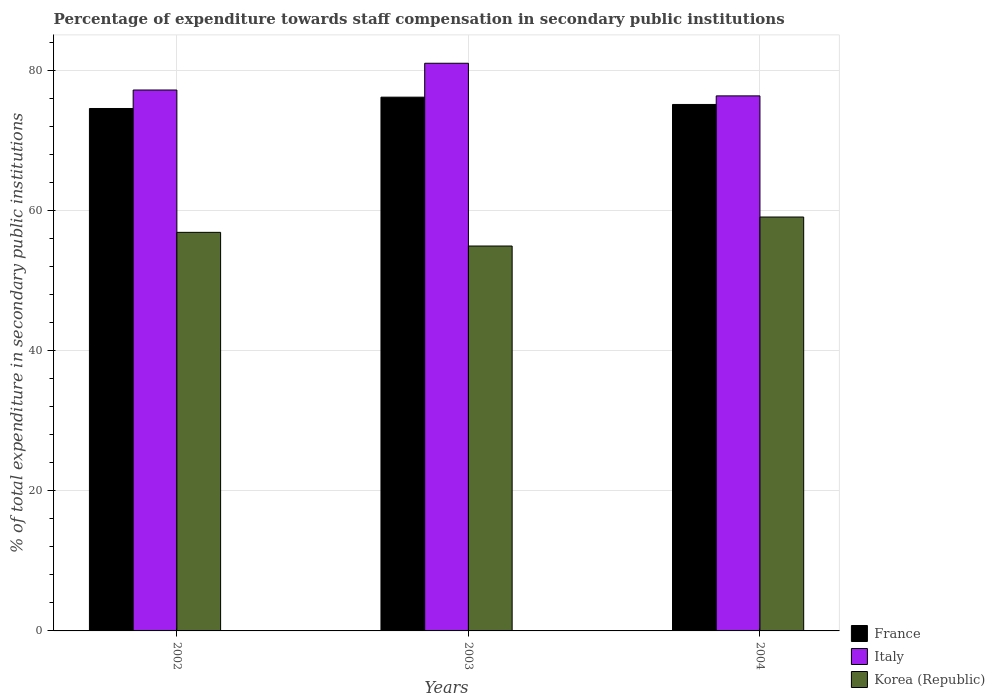How many groups of bars are there?
Offer a terse response. 3. Are the number of bars per tick equal to the number of legend labels?
Ensure brevity in your answer.  Yes. What is the label of the 2nd group of bars from the left?
Your answer should be very brief. 2003. What is the percentage of expenditure towards staff compensation in Korea (Republic) in 2002?
Provide a short and direct response. 56.87. Across all years, what is the maximum percentage of expenditure towards staff compensation in Korea (Republic)?
Provide a succinct answer. 59.06. Across all years, what is the minimum percentage of expenditure towards staff compensation in Korea (Republic)?
Make the answer very short. 54.92. In which year was the percentage of expenditure towards staff compensation in France minimum?
Keep it short and to the point. 2002. What is the total percentage of expenditure towards staff compensation in France in the graph?
Your response must be concise. 225.84. What is the difference between the percentage of expenditure towards staff compensation in Italy in 2003 and that in 2004?
Ensure brevity in your answer.  4.66. What is the difference between the percentage of expenditure towards staff compensation in Italy in 2003 and the percentage of expenditure towards staff compensation in France in 2002?
Your answer should be compact. 6.45. What is the average percentage of expenditure towards staff compensation in Italy per year?
Keep it short and to the point. 78.18. In the year 2002, what is the difference between the percentage of expenditure towards staff compensation in Korea (Republic) and percentage of expenditure towards staff compensation in Italy?
Keep it short and to the point. -20.31. What is the ratio of the percentage of expenditure towards staff compensation in France in 2002 to that in 2003?
Ensure brevity in your answer.  0.98. Is the difference between the percentage of expenditure towards staff compensation in Korea (Republic) in 2002 and 2004 greater than the difference between the percentage of expenditure towards staff compensation in Italy in 2002 and 2004?
Keep it short and to the point. No. What is the difference between the highest and the second highest percentage of expenditure towards staff compensation in Korea (Republic)?
Your response must be concise. 2.19. What is the difference between the highest and the lowest percentage of expenditure towards staff compensation in France?
Your answer should be very brief. 1.61. In how many years, is the percentage of expenditure towards staff compensation in Italy greater than the average percentage of expenditure towards staff compensation in Italy taken over all years?
Make the answer very short. 1. What does the 1st bar from the left in 2004 represents?
Give a very brief answer. France. Is it the case that in every year, the sum of the percentage of expenditure towards staff compensation in Italy and percentage of expenditure towards staff compensation in France is greater than the percentage of expenditure towards staff compensation in Korea (Republic)?
Provide a short and direct response. Yes. Are all the bars in the graph horizontal?
Your answer should be very brief. No. Are the values on the major ticks of Y-axis written in scientific E-notation?
Give a very brief answer. No. Where does the legend appear in the graph?
Your response must be concise. Bottom right. How are the legend labels stacked?
Give a very brief answer. Vertical. What is the title of the graph?
Provide a short and direct response. Percentage of expenditure towards staff compensation in secondary public institutions. Does "Congo (Republic)" appear as one of the legend labels in the graph?
Provide a short and direct response. No. What is the label or title of the X-axis?
Offer a very short reply. Years. What is the label or title of the Y-axis?
Keep it short and to the point. % of total expenditure in secondary public institutions. What is the % of total expenditure in secondary public institutions in France in 2002?
Make the answer very short. 74.55. What is the % of total expenditure in secondary public institutions in Italy in 2002?
Provide a short and direct response. 77.19. What is the % of total expenditure in secondary public institutions of Korea (Republic) in 2002?
Provide a short and direct response. 56.87. What is the % of total expenditure in secondary public institutions of France in 2003?
Offer a terse response. 76.16. What is the % of total expenditure in secondary public institutions of Italy in 2003?
Your answer should be very brief. 81. What is the % of total expenditure in secondary public institutions in Korea (Republic) in 2003?
Provide a short and direct response. 54.92. What is the % of total expenditure in secondary public institutions of France in 2004?
Make the answer very short. 75.12. What is the % of total expenditure in secondary public institutions in Italy in 2004?
Give a very brief answer. 76.35. What is the % of total expenditure in secondary public institutions of Korea (Republic) in 2004?
Offer a terse response. 59.06. Across all years, what is the maximum % of total expenditure in secondary public institutions in France?
Provide a short and direct response. 76.16. Across all years, what is the maximum % of total expenditure in secondary public institutions in Italy?
Give a very brief answer. 81. Across all years, what is the maximum % of total expenditure in secondary public institutions in Korea (Republic)?
Keep it short and to the point. 59.06. Across all years, what is the minimum % of total expenditure in secondary public institutions in France?
Give a very brief answer. 74.55. Across all years, what is the minimum % of total expenditure in secondary public institutions of Italy?
Provide a short and direct response. 76.35. Across all years, what is the minimum % of total expenditure in secondary public institutions of Korea (Republic)?
Provide a succinct answer. 54.92. What is the total % of total expenditure in secondary public institutions in France in the graph?
Make the answer very short. 225.84. What is the total % of total expenditure in secondary public institutions of Italy in the graph?
Your answer should be compact. 234.54. What is the total % of total expenditure in secondary public institutions in Korea (Republic) in the graph?
Ensure brevity in your answer.  170.86. What is the difference between the % of total expenditure in secondary public institutions of France in 2002 and that in 2003?
Your response must be concise. -1.61. What is the difference between the % of total expenditure in secondary public institutions in Italy in 2002 and that in 2003?
Provide a succinct answer. -3.82. What is the difference between the % of total expenditure in secondary public institutions of Korea (Republic) in 2002 and that in 2003?
Your answer should be compact. 1.95. What is the difference between the % of total expenditure in secondary public institutions of France in 2002 and that in 2004?
Provide a short and direct response. -0.57. What is the difference between the % of total expenditure in secondary public institutions of Italy in 2002 and that in 2004?
Your answer should be very brief. 0.84. What is the difference between the % of total expenditure in secondary public institutions in Korea (Republic) in 2002 and that in 2004?
Ensure brevity in your answer.  -2.19. What is the difference between the % of total expenditure in secondary public institutions in France in 2003 and that in 2004?
Your response must be concise. 1.04. What is the difference between the % of total expenditure in secondary public institutions of Italy in 2003 and that in 2004?
Give a very brief answer. 4.66. What is the difference between the % of total expenditure in secondary public institutions of Korea (Republic) in 2003 and that in 2004?
Keep it short and to the point. -4.14. What is the difference between the % of total expenditure in secondary public institutions of France in 2002 and the % of total expenditure in secondary public institutions of Italy in 2003?
Your response must be concise. -6.45. What is the difference between the % of total expenditure in secondary public institutions in France in 2002 and the % of total expenditure in secondary public institutions in Korea (Republic) in 2003?
Your answer should be very brief. 19.62. What is the difference between the % of total expenditure in secondary public institutions in Italy in 2002 and the % of total expenditure in secondary public institutions in Korea (Republic) in 2003?
Your answer should be very brief. 22.26. What is the difference between the % of total expenditure in secondary public institutions of France in 2002 and the % of total expenditure in secondary public institutions of Italy in 2004?
Offer a very short reply. -1.8. What is the difference between the % of total expenditure in secondary public institutions of France in 2002 and the % of total expenditure in secondary public institutions of Korea (Republic) in 2004?
Offer a very short reply. 15.49. What is the difference between the % of total expenditure in secondary public institutions in Italy in 2002 and the % of total expenditure in secondary public institutions in Korea (Republic) in 2004?
Your response must be concise. 18.13. What is the difference between the % of total expenditure in secondary public institutions of France in 2003 and the % of total expenditure in secondary public institutions of Italy in 2004?
Your response must be concise. -0.18. What is the difference between the % of total expenditure in secondary public institutions of France in 2003 and the % of total expenditure in secondary public institutions of Korea (Republic) in 2004?
Keep it short and to the point. 17.1. What is the difference between the % of total expenditure in secondary public institutions in Italy in 2003 and the % of total expenditure in secondary public institutions in Korea (Republic) in 2004?
Keep it short and to the point. 21.94. What is the average % of total expenditure in secondary public institutions in France per year?
Offer a very short reply. 75.28. What is the average % of total expenditure in secondary public institutions in Italy per year?
Your response must be concise. 78.18. What is the average % of total expenditure in secondary public institutions of Korea (Republic) per year?
Give a very brief answer. 56.95. In the year 2002, what is the difference between the % of total expenditure in secondary public institutions of France and % of total expenditure in secondary public institutions of Italy?
Keep it short and to the point. -2.64. In the year 2002, what is the difference between the % of total expenditure in secondary public institutions of France and % of total expenditure in secondary public institutions of Korea (Republic)?
Ensure brevity in your answer.  17.67. In the year 2002, what is the difference between the % of total expenditure in secondary public institutions in Italy and % of total expenditure in secondary public institutions in Korea (Republic)?
Your response must be concise. 20.31. In the year 2003, what is the difference between the % of total expenditure in secondary public institutions of France and % of total expenditure in secondary public institutions of Italy?
Make the answer very short. -4.84. In the year 2003, what is the difference between the % of total expenditure in secondary public institutions of France and % of total expenditure in secondary public institutions of Korea (Republic)?
Ensure brevity in your answer.  21.24. In the year 2003, what is the difference between the % of total expenditure in secondary public institutions in Italy and % of total expenditure in secondary public institutions in Korea (Republic)?
Your answer should be compact. 26.08. In the year 2004, what is the difference between the % of total expenditure in secondary public institutions of France and % of total expenditure in secondary public institutions of Italy?
Ensure brevity in your answer.  -1.22. In the year 2004, what is the difference between the % of total expenditure in secondary public institutions of France and % of total expenditure in secondary public institutions of Korea (Republic)?
Your answer should be very brief. 16.06. In the year 2004, what is the difference between the % of total expenditure in secondary public institutions in Italy and % of total expenditure in secondary public institutions in Korea (Republic)?
Provide a short and direct response. 17.29. What is the ratio of the % of total expenditure in secondary public institutions in France in 2002 to that in 2003?
Your response must be concise. 0.98. What is the ratio of the % of total expenditure in secondary public institutions of Italy in 2002 to that in 2003?
Your answer should be very brief. 0.95. What is the ratio of the % of total expenditure in secondary public institutions in Korea (Republic) in 2002 to that in 2003?
Offer a very short reply. 1.04. What is the ratio of the % of total expenditure in secondary public institutions of France in 2003 to that in 2004?
Provide a short and direct response. 1.01. What is the ratio of the % of total expenditure in secondary public institutions of Italy in 2003 to that in 2004?
Give a very brief answer. 1.06. What is the difference between the highest and the second highest % of total expenditure in secondary public institutions in France?
Give a very brief answer. 1.04. What is the difference between the highest and the second highest % of total expenditure in secondary public institutions in Italy?
Ensure brevity in your answer.  3.82. What is the difference between the highest and the second highest % of total expenditure in secondary public institutions in Korea (Republic)?
Make the answer very short. 2.19. What is the difference between the highest and the lowest % of total expenditure in secondary public institutions of France?
Give a very brief answer. 1.61. What is the difference between the highest and the lowest % of total expenditure in secondary public institutions in Italy?
Your answer should be very brief. 4.66. What is the difference between the highest and the lowest % of total expenditure in secondary public institutions of Korea (Republic)?
Offer a terse response. 4.14. 